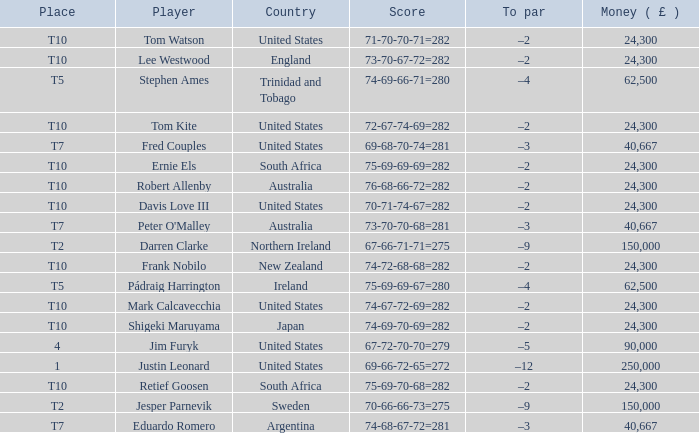What is Lee Westwood's score? 73-70-67-72=282. 